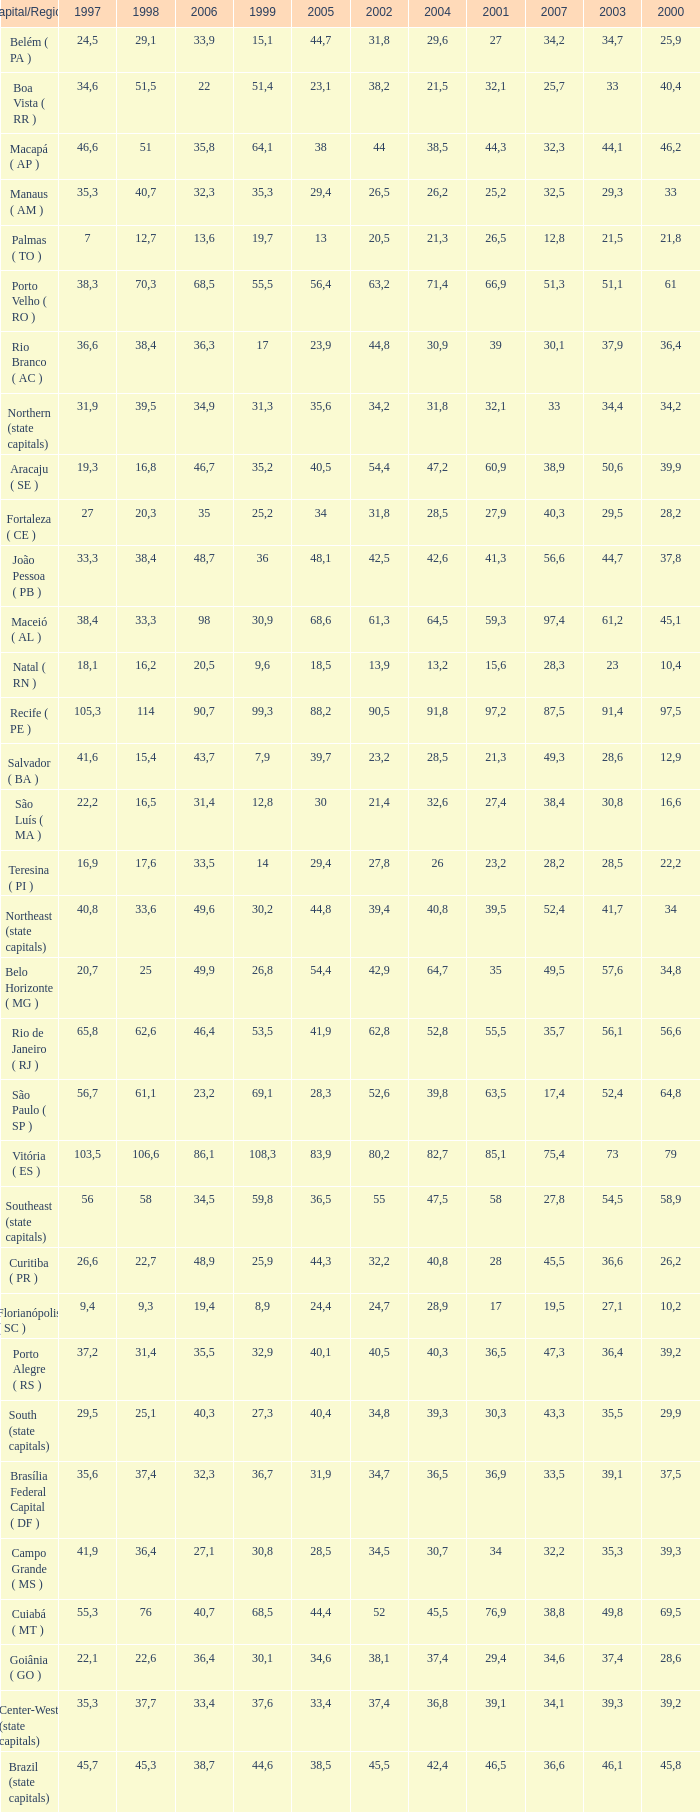How many 2007's have a 2000 greater than 56,6, 23,2 as 2006, and a 1998 greater than 61,1? None. 